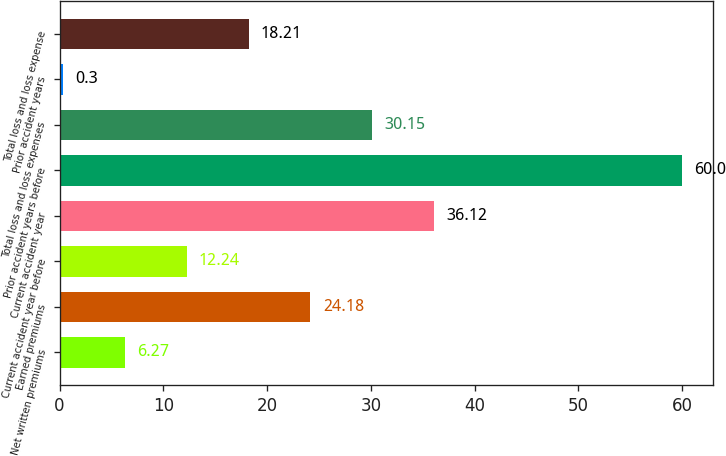<chart> <loc_0><loc_0><loc_500><loc_500><bar_chart><fcel>Net written premiums<fcel>Earned premiums<fcel>Current accident year before<fcel>Current accident year<fcel>Prior accident years before<fcel>Total loss and loss expenses<fcel>Prior accident years<fcel>Total loss and loss expense<nl><fcel>6.27<fcel>24.18<fcel>12.24<fcel>36.12<fcel>60<fcel>30.15<fcel>0.3<fcel>18.21<nl></chart> 